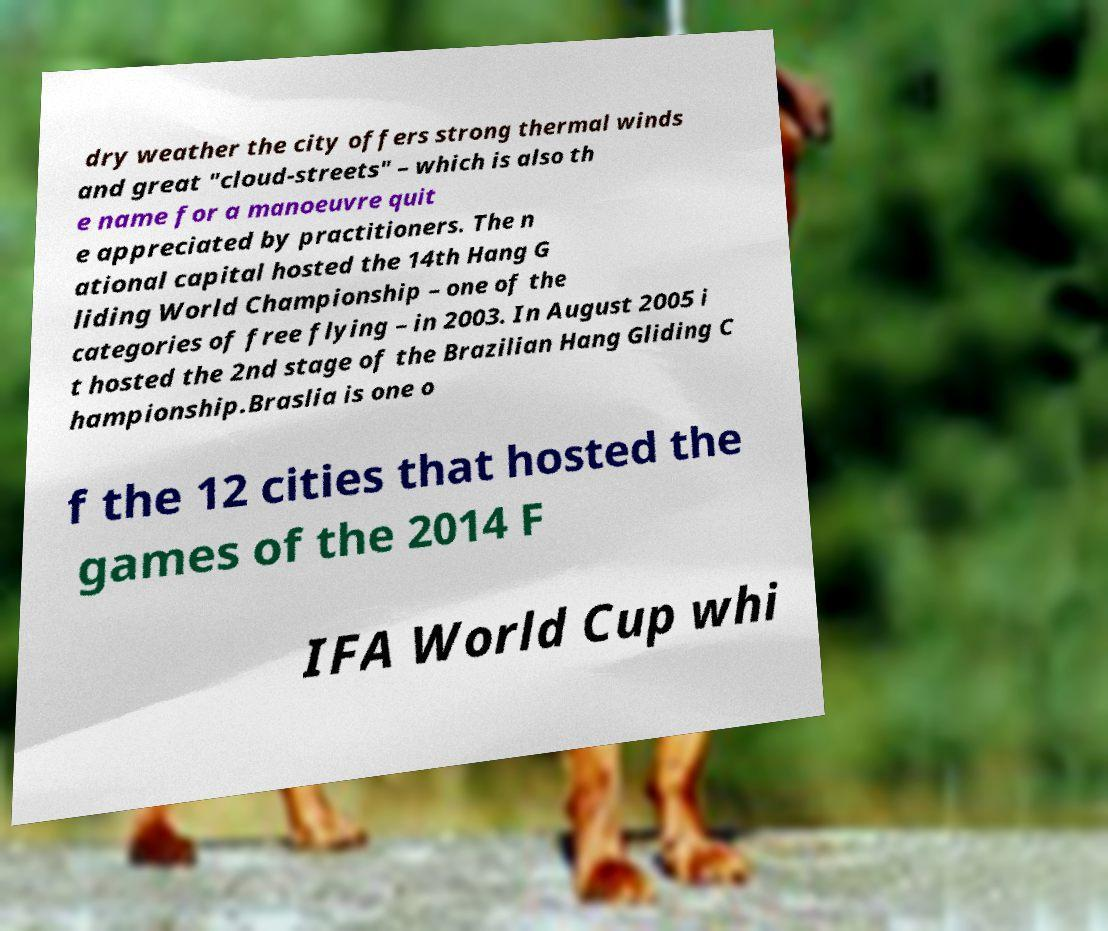Please read and relay the text visible in this image. What does it say? dry weather the city offers strong thermal winds and great "cloud-streets" – which is also th e name for a manoeuvre quit e appreciated by practitioners. The n ational capital hosted the 14th Hang G liding World Championship – one of the categories of free flying – in 2003. In August 2005 i t hosted the 2nd stage of the Brazilian Hang Gliding C hampionship.Braslia is one o f the 12 cities that hosted the games of the 2014 F IFA World Cup whi 